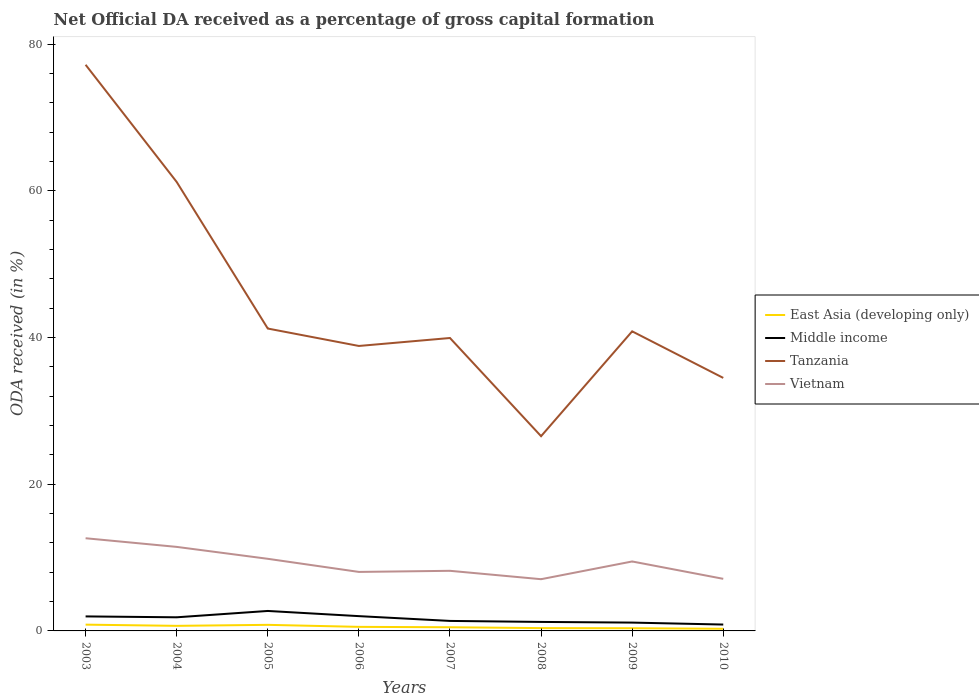Across all years, what is the maximum net ODA received in East Asia (developing only)?
Make the answer very short. 0.29. What is the total net ODA received in Middle income in the graph?
Provide a short and direct response. 0.63. What is the difference between the highest and the second highest net ODA received in East Asia (developing only)?
Offer a terse response. 0.56. What is the difference between the highest and the lowest net ODA received in East Asia (developing only)?
Your response must be concise. 3. Is the net ODA received in Tanzania strictly greater than the net ODA received in Middle income over the years?
Ensure brevity in your answer.  No. How many lines are there?
Give a very brief answer. 4. How many years are there in the graph?
Keep it short and to the point. 8. Does the graph contain grids?
Keep it short and to the point. No. How many legend labels are there?
Offer a terse response. 4. What is the title of the graph?
Offer a terse response. Net Official DA received as a percentage of gross capital formation. Does "France" appear as one of the legend labels in the graph?
Your answer should be compact. No. What is the label or title of the X-axis?
Your response must be concise. Years. What is the label or title of the Y-axis?
Your answer should be compact. ODA received (in %). What is the ODA received (in %) in East Asia (developing only) in 2003?
Your answer should be compact. 0.86. What is the ODA received (in %) in Middle income in 2003?
Your answer should be compact. 1.98. What is the ODA received (in %) in Tanzania in 2003?
Give a very brief answer. 77.21. What is the ODA received (in %) of Vietnam in 2003?
Offer a very short reply. 12.64. What is the ODA received (in %) of East Asia (developing only) in 2004?
Make the answer very short. 0.69. What is the ODA received (in %) in Middle income in 2004?
Provide a short and direct response. 1.86. What is the ODA received (in %) of Tanzania in 2004?
Make the answer very short. 61.23. What is the ODA received (in %) of Vietnam in 2004?
Keep it short and to the point. 11.46. What is the ODA received (in %) in East Asia (developing only) in 2005?
Make the answer very short. 0.83. What is the ODA received (in %) in Middle income in 2005?
Your response must be concise. 2.72. What is the ODA received (in %) in Tanzania in 2005?
Give a very brief answer. 41.24. What is the ODA received (in %) in Vietnam in 2005?
Make the answer very short. 9.84. What is the ODA received (in %) of East Asia (developing only) in 2006?
Offer a terse response. 0.55. What is the ODA received (in %) in Middle income in 2006?
Ensure brevity in your answer.  2.02. What is the ODA received (in %) of Tanzania in 2006?
Keep it short and to the point. 38.86. What is the ODA received (in %) in Vietnam in 2006?
Keep it short and to the point. 8.05. What is the ODA received (in %) of East Asia (developing only) in 2007?
Your answer should be very brief. 0.5. What is the ODA received (in %) in Middle income in 2007?
Your answer should be very brief. 1.36. What is the ODA received (in %) in Tanzania in 2007?
Keep it short and to the point. 39.95. What is the ODA received (in %) in Vietnam in 2007?
Ensure brevity in your answer.  8.2. What is the ODA received (in %) in East Asia (developing only) in 2008?
Offer a very short reply. 0.38. What is the ODA received (in %) of Middle income in 2008?
Your answer should be very brief. 1.23. What is the ODA received (in %) in Tanzania in 2008?
Ensure brevity in your answer.  26.56. What is the ODA received (in %) of Vietnam in 2008?
Provide a short and direct response. 7.05. What is the ODA received (in %) of East Asia (developing only) in 2009?
Ensure brevity in your answer.  0.37. What is the ODA received (in %) of Middle income in 2009?
Offer a very short reply. 1.14. What is the ODA received (in %) of Tanzania in 2009?
Provide a succinct answer. 40.86. What is the ODA received (in %) of Vietnam in 2009?
Make the answer very short. 9.47. What is the ODA received (in %) of East Asia (developing only) in 2010?
Keep it short and to the point. 0.29. What is the ODA received (in %) in Middle income in 2010?
Your answer should be compact. 0.87. What is the ODA received (in %) in Tanzania in 2010?
Your response must be concise. 34.51. What is the ODA received (in %) in Vietnam in 2010?
Give a very brief answer. 7.1. Across all years, what is the maximum ODA received (in %) of East Asia (developing only)?
Your response must be concise. 0.86. Across all years, what is the maximum ODA received (in %) in Middle income?
Your answer should be compact. 2.72. Across all years, what is the maximum ODA received (in %) of Tanzania?
Offer a very short reply. 77.21. Across all years, what is the maximum ODA received (in %) in Vietnam?
Offer a terse response. 12.64. Across all years, what is the minimum ODA received (in %) of East Asia (developing only)?
Ensure brevity in your answer.  0.29. Across all years, what is the minimum ODA received (in %) in Middle income?
Your answer should be compact. 0.87. Across all years, what is the minimum ODA received (in %) of Tanzania?
Your response must be concise. 26.56. Across all years, what is the minimum ODA received (in %) of Vietnam?
Make the answer very short. 7.05. What is the total ODA received (in %) in East Asia (developing only) in the graph?
Your answer should be compact. 4.48. What is the total ODA received (in %) in Middle income in the graph?
Ensure brevity in your answer.  13.17. What is the total ODA received (in %) in Tanzania in the graph?
Your response must be concise. 360.41. What is the total ODA received (in %) of Vietnam in the graph?
Provide a short and direct response. 73.81. What is the difference between the ODA received (in %) of East Asia (developing only) in 2003 and that in 2004?
Keep it short and to the point. 0.16. What is the difference between the ODA received (in %) in Middle income in 2003 and that in 2004?
Offer a terse response. 0.12. What is the difference between the ODA received (in %) in Tanzania in 2003 and that in 2004?
Give a very brief answer. 15.98. What is the difference between the ODA received (in %) in Vietnam in 2003 and that in 2004?
Your response must be concise. 1.18. What is the difference between the ODA received (in %) of East Asia (developing only) in 2003 and that in 2005?
Your answer should be compact. 0.03. What is the difference between the ODA received (in %) of Middle income in 2003 and that in 2005?
Provide a short and direct response. -0.74. What is the difference between the ODA received (in %) in Tanzania in 2003 and that in 2005?
Ensure brevity in your answer.  35.97. What is the difference between the ODA received (in %) in Vietnam in 2003 and that in 2005?
Give a very brief answer. 2.8. What is the difference between the ODA received (in %) in East Asia (developing only) in 2003 and that in 2006?
Your answer should be very brief. 0.3. What is the difference between the ODA received (in %) of Middle income in 2003 and that in 2006?
Offer a terse response. -0.04. What is the difference between the ODA received (in %) in Tanzania in 2003 and that in 2006?
Make the answer very short. 38.35. What is the difference between the ODA received (in %) of Vietnam in 2003 and that in 2006?
Provide a succinct answer. 4.59. What is the difference between the ODA received (in %) of East Asia (developing only) in 2003 and that in 2007?
Keep it short and to the point. 0.36. What is the difference between the ODA received (in %) of Middle income in 2003 and that in 2007?
Provide a short and direct response. 0.62. What is the difference between the ODA received (in %) in Tanzania in 2003 and that in 2007?
Provide a short and direct response. 37.26. What is the difference between the ODA received (in %) of Vietnam in 2003 and that in 2007?
Provide a short and direct response. 4.44. What is the difference between the ODA received (in %) in East Asia (developing only) in 2003 and that in 2008?
Your answer should be compact. 0.47. What is the difference between the ODA received (in %) of Middle income in 2003 and that in 2008?
Provide a succinct answer. 0.75. What is the difference between the ODA received (in %) in Tanzania in 2003 and that in 2008?
Ensure brevity in your answer.  50.65. What is the difference between the ODA received (in %) of Vietnam in 2003 and that in 2008?
Provide a short and direct response. 5.58. What is the difference between the ODA received (in %) in East Asia (developing only) in 2003 and that in 2009?
Offer a very short reply. 0.49. What is the difference between the ODA received (in %) of Middle income in 2003 and that in 2009?
Give a very brief answer. 0.84. What is the difference between the ODA received (in %) of Tanzania in 2003 and that in 2009?
Provide a succinct answer. 36.35. What is the difference between the ODA received (in %) of Vietnam in 2003 and that in 2009?
Provide a succinct answer. 3.17. What is the difference between the ODA received (in %) in East Asia (developing only) in 2003 and that in 2010?
Make the answer very short. 0.56. What is the difference between the ODA received (in %) in Middle income in 2003 and that in 2010?
Your response must be concise. 1.11. What is the difference between the ODA received (in %) of Tanzania in 2003 and that in 2010?
Your answer should be very brief. 42.7. What is the difference between the ODA received (in %) of Vietnam in 2003 and that in 2010?
Offer a terse response. 5.53. What is the difference between the ODA received (in %) of East Asia (developing only) in 2004 and that in 2005?
Provide a short and direct response. -0.14. What is the difference between the ODA received (in %) of Middle income in 2004 and that in 2005?
Offer a terse response. -0.86. What is the difference between the ODA received (in %) of Tanzania in 2004 and that in 2005?
Give a very brief answer. 19.99. What is the difference between the ODA received (in %) of Vietnam in 2004 and that in 2005?
Offer a terse response. 1.62. What is the difference between the ODA received (in %) in East Asia (developing only) in 2004 and that in 2006?
Make the answer very short. 0.14. What is the difference between the ODA received (in %) in Middle income in 2004 and that in 2006?
Ensure brevity in your answer.  -0.16. What is the difference between the ODA received (in %) of Tanzania in 2004 and that in 2006?
Make the answer very short. 22.37. What is the difference between the ODA received (in %) in Vietnam in 2004 and that in 2006?
Provide a short and direct response. 3.41. What is the difference between the ODA received (in %) in East Asia (developing only) in 2004 and that in 2007?
Keep it short and to the point. 0.19. What is the difference between the ODA received (in %) in Middle income in 2004 and that in 2007?
Offer a terse response. 0.5. What is the difference between the ODA received (in %) in Tanzania in 2004 and that in 2007?
Keep it short and to the point. 21.28. What is the difference between the ODA received (in %) in Vietnam in 2004 and that in 2007?
Your answer should be compact. 3.26. What is the difference between the ODA received (in %) in East Asia (developing only) in 2004 and that in 2008?
Keep it short and to the point. 0.31. What is the difference between the ODA received (in %) in Middle income in 2004 and that in 2008?
Your answer should be very brief. 0.63. What is the difference between the ODA received (in %) of Tanzania in 2004 and that in 2008?
Your answer should be very brief. 34.67. What is the difference between the ODA received (in %) in Vietnam in 2004 and that in 2008?
Provide a short and direct response. 4.41. What is the difference between the ODA received (in %) of East Asia (developing only) in 2004 and that in 2009?
Give a very brief answer. 0.33. What is the difference between the ODA received (in %) of Middle income in 2004 and that in 2009?
Offer a very short reply. 0.72. What is the difference between the ODA received (in %) in Tanzania in 2004 and that in 2009?
Provide a succinct answer. 20.37. What is the difference between the ODA received (in %) in Vietnam in 2004 and that in 2009?
Make the answer very short. 1.99. What is the difference between the ODA received (in %) in East Asia (developing only) in 2004 and that in 2010?
Keep it short and to the point. 0.4. What is the difference between the ODA received (in %) of Tanzania in 2004 and that in 2010?
Keep it short and to the point. 26.72. What is the difference between the ODA received (in %) of Vietnam in 2004 and that in 2010?
Offer a terse response. 4.35. What is the difference between the ODA received (in %) in East Asia (developing only) in 2005 and that in 2006?
Give a very brief answer. 0.27. What is the difference between the ODA received (in %) in Middle income in 2005 and that in 2006?
Keep it short and to the point. 0.71. What is the difference between the ODA received (in %) of Tanzania in 2005 and that in 2006?
Give a very brief answer. 2.38. What is the difference between the ODA received (in %) of Vietnam in 2005 and that in 2006?
Your answer should be very brief. 1.79. What is the difference between the ODA received (in %) of East Asia (developing only) in 2005 and that in 2007?
Provide a succinct answer. 0.33. What is the difference between the ODA received (in %) of Middle income in 2005 and that in 2007?
Keep it short and to the point. 1.36. What is the difference between the ODA received (in %) of Tanzania in 2005 and that in 2007?
Give a very brief answer. 1.29. What is the difference between the ODA received (in %) of Vietnam in 2005 and that in 2007?
Give a very brief answer. 1.64. What is the difference between the ODA received (in %) of East Asia (developing only) in 2005 and that in 2008?
Offer a very short reply. 0.45. What is the difference between the ODA received (in %) of Middle income in 2005 and that in 2008?
Offer a terse response. 1.49. What is the difference between the ODA received (in %) in Tanzania in 2005 and that in 2008?
Offer a very short reply. 14.68. What is the difference between the ODA received (in %) of Vietnam in 2005 and that in 2008?
Provide a short and direct response. 2.78. What is the difference between the ODA received (in %) of East Asia (developing only) in 2005 and that in 2009?
Provide a short and direct response. 0.46. What is the difference between the ODA received (in %) of Middle income in 2005 and that in 2009?
Your answer should be very brief. 1.59. What is the difference between the ODA received (in %) of Tanzania in 2005 and that in 2009?
Provide a succinct answer. 0.38. What is the difference between the ODA received (in %) in Vietnam in 2005 and that in 2009?
Ensure brevity in your answer.  0.36. What is the difference between the ODA received (in %) of East Asia (developing only) in 2005 and that in 2010?
Ensure brevity in your answer.  0.54. What is the difference between the ODA received (in %) in Middle income in 2005 and that in 2010?
Offer a very short reply. 1.85. What is the difference between the ODA received (in %) of Tanzania in 2005 and that in 2010?
Offer a terse response. 6.73. What is the difference between the ODA received (in %) in Vietnam in 2005 and that in 2010?
Your answer should be very brief. 2.73. What is the difference between the ODA received (in %) of East Asia (developing only) in 2006 and that in 2007?
Offer a very short reply. 0.05. What is the difference between the ODA received (in %) of Middle income in 2006 and that in 2007?
Offer a very short reply. 0.65. What is the difference between the ODA received (in %) of Tanzania in 2006 and that in 2007?
Your response must be concise. -1.09. What is the difference between the ODA received (in %) in Vietnam in 2006 and that in 2007?
Make the answer very short. -0.15. What is the difference between the ODA received (in %) in East Asia (developing only) in 2006 and that in 2008?
Your answer should be very brief. 0.17. What is the difference between the ODA received (in %) of Middle income in 2006 and that in 2008?
Your response must be concise. 0.79. What is the difference between the ODA received (in %) in Tanzania in 2006 and that in 2008?
Your answer should be compact. 12.3. What is the difference between the ODA received (in %) of East Asia (developing only) in 2006 and that in 2009?
Your response must be concise. 0.19. What is the difference between the ODA received (in %) in Middle income in 2006 and that in 2009?
Provide a short and direct response. 0.88. What is the difference between the ODA received (in %) in Tanzania in 2006 and that in 2009?
Offer a terse response. -1.99. What is the difference between the ODA received (in %) of Vietnam in 2006 and that in 2009?
Make the answer very short. -1.43. What is the difference between the ODA received (in %) of East Asia (developing only) in 2006 and that in 2010?
Ensure brevity in your answer.  0.26. What is the difference between the ODA received (in %) in Middle income in 2006 and that in 2010?
Offer a terse response. 1.15. What is the difference between the ODA received (in %) in Tanzania in 2006 and that in 2010?
Provide a succinct answer. 4.36. What is the difference between the ODA received (in %) in Vietnam in 2006 and that in 2010?
Provide a short and direct response. 0.94. What is the difference between the ODA received (in %) in East Asia (developing only) in 2007 and that in 2008?
Provide a short and direct response. 0.12. What is the difference between the ODA received (in %) in Middle income in 2007 and that in 2008?
Provide a short and direct response. 0.13. What is the difference between the ODA received (in %) in Tanzania in 2007 and that in 2008?
Give a very brief answer. 13.39. What is the difference between the ODA received (in %) in Vietnam in 2007 and that in 2008?
Provide a short and direct response. 1.14. What is the difference between the ODA received (in %) of East Asia (developing only) in 2007 and that in 2009?
Your answer should be compact. 0.13. What is the difference between the ODA received (in %) in Middle income in 2007 and that in 2009?
Your answer should be very brief. 0.23. What is the difference between the ODA received (in %) of Tanzania in 2007 and that in 2009?
Offer a very short reply. -0.91. What is the difference between the ODA received (in %) of Vietnam in 2007 and that in 2009?
Offer a terse response. -1.27. What is the difference between the ODA received (in %) in East Asia (developing only) in 2007 and that in 2010?
Give a very brief answer. 0.21. What is the difference between the ODA received (in %) of Middle income in 2007 and that in 2010?
Your answer should be very brief. 0.49. What is the difference between the ODA received (in %) in Tanzania in 2007 and that in 2010?
Provide a short and direct response. 5.44. What is the difference between the ODA received (in %) in Vietnam in 2007 and that in 2010?
Offer a very short reply. 1.09. What is the difference between the ODA received (in %) of East Asia (developing only) in 2008 and that in 2009?
Your answer should be very brief. 0.02. What is the difference between the ODA received (in %) of Middle income in 2008 and that in 2009?
Provide a short and direct response. 0.09. What is the difference between the ODA received (in %) in Tanzania in 2008 and that in 2009?
Provide a short and direct response. -14.3. What is the difference between the ODA received (in %) of Vietnam in 2008 and that in 2009?
Your answer should be compact. -2.42. What is the difference between the ODA received (in %) of East Asia (developing only) in 2008 and that in 2010?
Provide a short and direct response. 0.09. What is the difference between the ODA received (in %) in Middle income in 2008 and that in 2010?
Provide a succinct answer. 0.36. What is the difference between the ODA received (in %) of Tanzania in 2008 and that in 2010?
Provide a succinct answer. -7.95. What is the difference between the ODA received (in %) in Vietnam in 2008 and that in 2010?
Your answer should be compact. -0.05. What is the difference between the ODA received (in %) of East Asia (developing only) in 2009 and that in 2010?
Your answer should be very brief. 0.07. What is the difference between the ODA received (in %) in Middle income in 2009 and that in 2010?
Your response must be concise. 0.27. What is the difference between the ODA received (in %) in Tanzania in 2009 and that in 2010?
Give a very brief answer. 6.35. What is the difference between the ODA received (in %) in Vietnam in 2009 and that in 2010?
Your answer should be compact. 2.37. What is the difference between the ODA received (in %) of East Asia (developing only) in 2003 and the ODA received (in %) of Middle income in 2004?
Keep it short and to the point. -1. What is the difference between the ODA received (in %) in East Asia (developing only) in 2003 and the ODA received (in %) in Tanzania in 2004?
Your answer should be compact. -60.37. What is the difference between the ODA received (in %) in East Asia (developing only) in 2003 and the ODA received (in %) in Vietnam in 2004?
Keep it short and to the point. -10.6. What is the difference between the ODA received (in %) of Middle income in 2003 and the ODA received (in %) of Tanzania in 2004?
Provide a succinct answer. -59.25. What is the difference between the ODA received (in %) of Middle income in 2003 and the ODA received (in %) of Vietnam in 2004?
Your answer should be very brief. -9.48. What is the difference between the ODA received (in %) in Tanzania in 2003 and the ODA received (in %) in Vietnam in 2004?
Ensure brevity in your answer.  65.75. What is the difference between the ODA received (in %) of East Asia (developing only) in 2003 and the ODA received (in %) of Middle income in 2005?
Make the answer very short. -1.87. What is the difference between the ODA received (in %) in East Asia (developing only) in 2003 and the ODA received (in %) in Tanzania in 2005?
Ensure brevity in your answer.  -40.38. What is the difference between the ODA received (in %) of East Asia (developing only) in 2003 and the ODA received (in %) of Vietnam in 2005?
Provide a short and direct response. -8.98. What is the difference between the ODA received (in %) of Middle income in 2003 and the ODA received (in %) of Tanzania in 2005?
Keep it short and to the point. -39.26. What is the difference between the ODA received (in %) in Middle income in 2003 and the ODA received (in %) in Vietnam in 2005?
Offer a very short reply. -7.86. What is the difference between the ODA received (in %) of Tanzania in 2003 and the ODA received (in %) of Vietnam in 2005?
Your answer should be compact. 67.37. What is the difference between the ODA received (in %) in East Asia (developing only) in 2003 and the ODA received (in %) in Middle income in 2006?
Your answer should be very brief. -1.16. What is the difference between the ODA received (in %) in East Asia (developing only) in 2003 and the ODA received (in %) in Tanzania in 2006?
Provide a succinct answer. -38.01. What is the difference between the ODA received (in %) of East Asia (developing only) in 2003 and the ODA received (in %) of Vietnam in 2006?
Your response must be concise. -7.19. What is the difference between the ODA received (in %) in Middle income in 2003 and the ODA received (in %) in Tanzania in 2006?
Your response must be concise. -36.88. What is the difference between the ODA received (in %) in Middle income in 2003 and the ODA received (in %) in Vietnam in 2006?
Ensure brevity in your answer.  -6.07. What is the difference between the ODA received (in %) of Tanzania in 2003 and the ODA received (in %) of Vietnam in 2006?
Give a very brief answer. 69.16. What is the difference between the ODA received (in %) of East Asia (developing only) in 2003 and the ODA received (in %) of Middle income in 2007?
Provide a short and direct response. -0.51. What is the difference between the ODA received (in %) in East Asia (developing only) in 2003 and the ODA received (in %) in Tanzania in 2007?
Offer a terse response. -39.09. What is the difference between the ODA received (in %) of East Asia (developing only) in 2003 and the ODA received (in %) of Vietnam in 2007?
Offer a very short reply. -7.34. What is the difference between the ODA received (in %) of Middle income in 2003 and the ODA received (in %) of Tanzania in 2007?
Your response must be concise. -37.97. What is the difference between the ODA received (in %) in Middle income in 2003 and the ODA received (in %) in Vietnam in 2007?
Keep it short and to the point. -6.22. What is the difference between the ODA received (in %) of Tanzania in 2003 and the ODA received (in %) of Vietnam in 2007?
Offer a very short reply. 69.01. What is the difference between the ODA received (in %) of East Asia (developing only) in 2003 and the ODA received (in %) of Middle income in 2008?
Your response must be concise. -0.37. What is the difference between the ODA received (in %) in East Asia (developing only) in 2003 and the ODA received (in %) in Tanzania in 2008?
Offer a very short reply. -25.7. What is the difference between the ODA received (in %) of East Asia (developing only) in 2003 and the ODA received (in %) of Vietnam in 2008?
Offer a terse response. -6.2. What is the difference between the ODA received (in %) of Middle income in 2003 and the ODA received (in %) of Tanzania in 2008?
Ensure brevity in your answer.  -24.58. What is the difference between the ODA received (in %) in Middle income in 2003 and the ODA received (in %) in Vietnam in 2008?
Offer a terse response. -5.07. What is the difference between the ODA received (in %) of Tanzania in 2003 and the ODA received (in %) of Vietnam in 2008?
Your answer should be very brief. 70.16. What is the difference between the ODA received (in %) of East Asia (developing only) in 2003 and the ODA received (in %) of Middle income in 2009?
Provide a succinct answer. -0.28. What is the difference between the ODA received (in %) of East Asia (developing only) in 2003 and the ODA received (in %) of Tanzania in 2009?
Your answer should be very brief. -40. What is the difference between the ODA received (in %) of East Asia (developing only) in 2003 and the ODA received (in %) of Vietnam in 2009?
Provide a succinct answer. -8.62. What is the difference between the ODA received (in %) in Middle income in 2003 and the ODA received (in %) in Tanzania in 2009?
Ensure brevity in your answer.  -38.88. What is the difference between the ODA received (in %) in Middle income in 2003 and the ODA received (in %) in Vietnam in 2009?
Your answer should be compact. -7.49. What is the difference between the ODA received (in %) in Tanzania in 2003 and the ODA received (in %) in Vietnam in 2009?
Ensure brevity in your answer.  67.74. What is the difference between the ODA received (in %) of East Asia (developing only) in 2003 and the ODA received (in %) of Middle income in 2010?
Your response must be concise. -0.01. What is the difference between the ODA received (in %) in East Asia (developing only) in 2003 and the ODA received (in %) in Tanzania in 2010?
Keep it short and to the point. -33.65. What is the difference between the ODA received (in %) in East Asia (developing only) in 2003 and the ODA received (in %) in Vietnam in 2010?
Provide a succinct answer. -6.25. What is the difference between the ODA received (in %) in Middle income in 2003 and the ODA received (in %) in Tanzania in 2010?
Provide a succinct answer. -32.53. What is the difference between the ODA received (in %) of Middle income in 2003 and the ODA received (in %) of Vietnam in 2010?
Offer a very short reply. -5.13. What is the difference between the ODA received (in %) in Tanzania in 2003 and the ODA received (in %) in Vietnam in 2010?
Provide a succinct answer. 70.1. What is the difference between the ODA received (in %) of East Asia (developing only) in 2004 and the ODA received (in %) of Middle income in 2005?
Provide a short and direct response. -2.03. What is the difference between the ODA received (in %) of East Asia (developing only) in 2004 and the ODA received (in %) of Tanzania in 2005?
Your answer should be very brief. -40.54. What is the difference between the ODA received (in %) in East Asia (developing only) in 2004 and the ODA received (in %) in Vietnam in 2005?
Your answer should be very brief. -9.14. What is the difference between the ODA received (in %) of Middle income in 2004 and the ODA received (in %) of Tanzania in 2005?
Your response must be concise. -39.38. What is the difference between the ODA received (in %) of Middle income in 2004 and the ODA received (in %) of Vietnam in 2005?
Offer a terse response. -7.98. What is the difference between the ODA received (in %) of Tanzania in 2004 and the ODA received (in %) of Vietnam in 2005?
Make the answer very short. 51.39. What is the difference between the ODA received (in %) in East Asia (developing only) in 2004 and the ODA received (in %) in Middle income in 2006?
Provide a succinct answer. -1.32. What is the difference between the ODA received (in %) in East Asia (developing only) in 2004 and the ODA received (in %) in Tanzania in 2006?
Offer a terse response. -38.17. What is the difference between the ODA received (in %) in East Asia (developing only) in 2004 and the ODA received (in %) in Vietnam in 2006?
Make the answer very short. -7.35. What is the difference between the ODA received (in %) in Middle income in 2004 and the ODA received (in %) in Tanzania in 2006?
Ensure brevity in your answer.  -37. What is the difference between the ODA received (in %) in Middle income in 2004 and the ODA received (in %) in Vietnam in 2006?
Give a very brief answer. -6.19. What is the difference between the ODA received (in %) of Tanzania in 2004 and the ODA received (in %) of Vietnam in 2006?
Offer a very short reply. 53.18. What is the difference between the ODA received (in %) of East Asia (developing only) in 2004 and the ODA received (in %) of Middle income in 2007?
Offer a terse response. -0.67. What is the difference between the ODA received (in %) of East Asia (developing only) in 2004 and the ODA received (in %) of Tanzania in 2007?
Make the answer very short. -39.25. What is the difference between the ODA received (in %) in East Asia (developing only) in 2004 and the ODA received (in %) in Vietnam in 2007?
Offer a very short reply. -7.5. What is the difference between the ODA received (in %) of Middle income in 2004 and the ODA received (in %) of Tanzania in 2007?
Give a very brief answer. -38.09. What is the difference between the ODA received (in %) of Middle income in 2004 and the ODA received (in %) of Vietnam in 2007?
Give a very brief answer. -6.34. What is the difference between the ODA received (in %) in Tanzania in 2004 and the ODA received (in %) in Vietnam in 2007?
Provide a succinct answer. 53.03. What is the difference between the ODA received (in %) in East Asia (developing only) in 2004 and the ODA received (in %) in Middle income in 2008?
Ensure brevity in your answer.  -0.53. What is the difference between the ODA received (in %) of East Asia (developing only) in 2004 and the ODA received (in %) of Tanzania in 2008?
Make the answer very short. -25.86. What is the difference between the ODA received (in %) in East Asia (developing only) in 2004 and the ODA received (in %) in Vietnam in 2008?
Provide a succinct answer. -6.36. What is the difference between the ODA received (in %) of Middle income in 2004 and the ODA received (in %) of Tanzania in 2008?
Your response must be concise. -24.7. What is the difference between the ODA received (in %) of Middle income in 2004 and the ODA received (in %) of Vietnam in 2008?
Offer a terse response. -5.2. What is the difference between the ODA received (in %) of Tanzania in 2004 and the ODA received (in %) of Vietnam in 2008?
Ensure brevity in your answer.  54.17. What is the difference between the ODA received (in %) of East Asia (developing only) in 2004 and the ODA received (in %) of Middle income in 2009?
Give a very brief answer. -0.44. What is the difference between the ODA received (in %) of East Asia (developing only) in 2004 and the ODA received (in %) of Tanzania in 2009?
Provide a succinct answer. -40.16. What is the difference between the ODA received (in %) in East Asia (developing only) in 2004 and the ODA received (in %) in Vietnam in 2009?
Offer a terse response. -8.78. What is the difference between the ODA received (in %) of Middle income in 2004 and the ODA received (in %) of Tanzania in 2009?
Give a very brief answer. -39. What is the difference between the ODA received (in %) in Middle income in 2004 and the ODA received (in %) in Vietnam in 2009?
Keep it short and to the point. -7.61. What is the difference between the ODA received (in %) of Tanzania in 2004 and the ODA received (in %) of Vietnam in 2009?
Offer a terse response. 51.76. What is the difference between the ODA received (in %) of East Asia (developing only) in 2004 and the ODA received (in %) of Middle income in 2010?
Your answer should be compact. -0.18. What is the difference between the ODA received (in %) of East Asia (developing only) in 2004 and the ODA received (in %) of Tanzania in 2010?
Provide a succinct answer. -33.81. What is the difference between the ODA received (in %) of East Asia (developing only) in 2004 and the ODA received (in %) of Vietnam in 2010?
Keep it short and to the point. -6.41. What is the difference between the ODA received (in %) in Middle income in 2004 and the ODA received (in %) in Tanzania in 2010?
Your answer should be compact. -32.65. What is the difference between the ODA received (in %) in Middle income in 2004 and the ODA received (in %) in Vietnam in 2010?
Make the answer very short. -5.25. What is the difference between the ODA received (in %) in Tanzania in 2004 and the ODA received (in %) in Vietnam in 2010?
Provide a short and direct response. 54.12. What is the difference between the ODA received (in %) in East Asia (developing only) in 2005 and the ODA received (in %) in Middle income in 2006?
Keep it short and to the point. -1.19. What is the difference between the ODA received (in %) in East Asia (developing only) in 2005 and the ODA received (in %) in Tanzania in 2006?
Your answer should be very brief. -38.03. What is the difference between the ODA received (in %) in East Asia (developing only) in 2005 and the ODA received (in %) in Vietnam in 2006?
Your answer should be very brief. -7.22. What is the difference between the ODA received (in %) of Middle income in 2005 and the ODA received (in %) of Tanzania in 2006?
Give a very brief answer. -36.14. What is the difference between the ODA received (in %) in Middle income in 2005 and the ODA received (in %) in Vietnam in 2006?
Offer a very short reply. -5.32. What is the difference between the ODA received (in %) of Tanzania in 2005 and the ODA received (in %) of Vietnam in 2006?
Offer a terse response. 33.19. What is the difference between the ODA received (in %) of East Asia (developing only) in 2005 and the ODA received (in %) of Middle income in 2007?
Give a very brief answer. -0.53. What is the difference between the ODA received (in %) of East Asia (developing only) in 2005 and the ODA received (in %) of Tanzania in 2007?
Make the answer very short. -39.12. What is the difference between the ODA received (in %) in East Asia (developing only) in 2005 and the ODA received (in %) in Vietnam in 2007?
Your answer should be very brief. -7.37. What is the difference between the ODA received (in %) in Middle income in 2005 and the ODA received (in %) in Tanzania in 2007?
Ensure brevity in your answer.  -37.23. What is the difference between the ODA received (in %) of Middle income in 2005 and the ODA received (in %) of Vietnam in 2007?
Offer a terse response. -5.47. What is the difference between the ODA received (in %) of Tanzania in 2005 and the ODA received (in %) of Vietnam in 2007?
Make the answer very short. 33.04. What is the difference between the ODA received (in %) of East Asia (developing only) in 2005 and the ODA received (in %) of Middle income in 2008?
Ensure brevity in your answer.  -0.4. What is the difference between the ODA received (in %) of East Asia (developing only) in 2005 and the ODA received (in %) of Tanzania in 2008?
Ensure brevity in your answer.  -25.73. What is the difference between the ODA received (in %) of East Asia (developing only) in 2005 and the ODA received (in %) of Vietnam in 2008?
Your answer should be very brief. -6.22. What is the difference between the ODA received (in %) in Middle income in 2005 and the ODA received (in %) in Tanzania in 2008?
Provide a short and direct response. -23.84. What is the difference between the ODA received (in %) in Middle income in 2005 and the ODA received (in %) in Vietnam in 2008?
Ensure brevity in your answer.  -4.33. What is the difference between the ODA received (in %) of Tanzania in 2005 and the ODA received (in %) of Vietnam in 2008?
Offer a very short reply. 34.18. What is the difference between the ODA received (in %) of East Asia (developing only) in 2005 and the ODA received (in %) of Middle income in 2009?
Offer a very short reply. -0.31. What is the difference between the ODA received (in %) of East Asia (developing only) in 2005 and the ODA received (in %) of Tanzania in 2009?
Your response must be concise. -40.03. What is the difference between the ODA received (in %) in East Asia (developing only) in 2005 and the ODA received (in %) in Vietnam in 2009?
Your answer should be very brief. -8.64. What is the difference between the ODA received (in %) in Middle income in 2005 and the ODA received (in %) in Tanzania in 2009?
Your answer should be very brief. -38.13. What is the difference between the ODA received (in %) in Middle income in 2005 and the ODA received (in %) in Vietnam in 2009?
Offer a very short reply. -6.75. What is the difference between the ODA received (in %) of Tanzania in 2005 and the ODA received (in %) of Vietnam in 2009?
Give a very brief answer. 31.77. What is the difference between the ODA received (in %) in East Asia (developing only) in 2005 and the ODA received (in %) in Middle income in 2010?
Your answer should be very brief. -0.04. What is the difference between the ODA received (in %) in East Asia (developing only) in 2005 and the ODA received (in %) in Tanzania in 2010?
Keep it short and to the point. -33.68. What is the difference between the ODA received (in %) of East Asia (developing only) in 2005 and the ODA received (in %) of Vietnam in 2010?
Offer a terse response. -6.28. What is the difference between the ODA received (in %) in Middle income in 2005 and the ODA received (in %) in Tanzania in 2010?
Offer a very short reply. -31.78. What is the difference between the ODA received (in %) in Middle income in 2005 and the ODA received (in %) in Vietnam in 2010?
Offer a very short reply. -4.38. What is the difference between the ODA received (in %) in Tanzania in 2005 and the ODA received (in %) in Vietnam in 2010?
Offer a terse response. 34.13. What is the difference between the ODA received (in %) of East Asia (developing only) in 2006 and the ODA received (in %) of Middle income in 2007?
Provide a succinct answer. -0.81. What is the difference between the ODA received (in %) in East Asia (developing only) in 2006 and the ODA received (in %) in Tanzania in 2007?
Your answer should be very brief. -39.39. What is the difference between the ODA received (in %) in East Asia (developing only) in 2006 and the ODA received (in %) in Vietnam in 2007?
Make the answer very short. -7.64. What is the difference between the ODA received (in %) in Middle income in 2006 and the ODA received (in %) in Tanzania in 2007?
Provide a succinct answer. -37.93. What is the difference between the ODA received (in %) in Middle income in 2006 and the ODA received (in %) in Vietnam in 2007?
Offer a very short reply. -6.18. What is the difference between the ODA received (in %) in Tanzania in 2006 and the ODA received (in %) in Vietnam in 2007?
Ensure brevity in your answer.  30.66. What is the difference between the ODA received (in %) of East Asia (developing only) in 2006 and the ODA received (in %) of Middle income in 2008?
Your response must be concise. -0.67. What is the difference between the ODA received (in %) in East Asia (developing only) in 2006 and the ODA received (in %) in Tanzania in 2008?
Provide a short and direct response. -26. What is the difference between the ODA received (in %) in East Asia (developing only) in 2006 and the ODA received (in %) in Vietnam in 2008?
Provide a short and direct response. -6.5. What is the difference between the ODA received (in %) of Middle income in 2006 and the ODA received (in %) of Tanzania in 2008?
Offer a very short reply. -24.54. What is the difference between the ODA received (in %) in Middle income in 2006 and the ODA received (in %) in Vietnam in 2008?
Your answer should be very brief. -5.04. What is the difference between the ODA received (in %) in Tanzania in 2006 and the ODA received (in %) in Vietnam in 2008?
Keep it short and to the point. 31.81. What is the difference between the ODA received (in %) of East Asia (developing only) in 2006 and the ODA received (in %) of Middle income in 2009?
Ensure brevity in your answer.  -0.58. What is the difference between the ODA received (in %) of East Asia (developing only) in 2006 and the ODA received (in %) of Tanzania in 2009?
Give a very brief answer. -40.3. What is the difference between the ODA received (in %) of East Asia (developing only) in 2006 and the ODA received (in %) of Vietnam in 2009?
Your answer should be compact. -8.92. What is the difference between the ODA received (in %) of Middle income in 2006 and the ODA received (in %) of Tanzania in 2009?
Keep it short and to the point. -38.84. What is the difference between the ODA received (in %) in Middle income in 2006 and the ODA received (in %) in Vietnam in 2009?
Give a very brief answer. -7.46. What is the difference between the ODA received (in %) in Tanzania in 2006 and the ODA received (in %) in Vietnam in 2009?
Your answer should be compact. 29.39. What is the difference between the ODA received (in %) in East Asia (developing only) in 2006 and the ODA received (in %) in Middle income in 2010?
Your response must be concise. -0.32. What is the difference between the ODA received (in %) of East Asia (developing only) in 2006 and the ODA received (in %) of Tanzania in 2010?
Provide a succinct answer. -33.95. What is the difference between the ODA received (in %) of East Asia (developing only) in 2006 and the ODA received (in %) of Vietnam in 2010?
Offer a terse response. -6.55. What is the difference between the ODA received (in %) of Middle income in 2006 and the ODA received (in %) of Tanzania in 2010?
Offer a very short reply. -32.49. What is the difference between the ODA received (in %) of Middle income in 2006 and the ODA received (in %) of Vietnam in 2010?
Make the answer very short. -5.09. What is the difference between the ODA received (in %) in Tanzania in 2006 and the ODA received (in %) in Vietnam in 2010?
Your response must be concise. 31.76. What is the difference between the ODA received (in %) of East Asia (developing only) in 2007 and the ODA received (in %) of Middle income in 2008?
Make the answer very short. -0.73. What is the difference between the ODA received (in %) in East Asia (developing only) in 2007 and the ODA received (in %) in Tanzania in 2008?
Keep it short and to the point. -26.06. What is the difference between the ODA received (in %) of East Asia (developing only) in 2007 and the ODA received (in %) of Vietnam in 2008?
Provide a succinct answer. -6.55. What is the difference between the ODA received (in %) of Middle income in 2007 and the ODA received (in %) of Tanzania in 2008?
Offer a terse response. -25.2. What is the difference between the ODA received (in %) in Middle income in 2007 and the ODA received (in %) in Vietnam in 2008?
Ensure brevity in your answer.  -5.69. What is the difference between the ODA received (in %) of Tanzania in 2007 and the ODA received (in %) of Vietnam in 2008?
Make the answer very short. 32.89. What is the difference between the ODA received (in %) in East Asia (developing only) in 2007 and the ODA received (in %) in Middle income in 2009?
Your answer should be very brief. -0.64. What is the difference between the ODA received (in %) in East Asia (developing only) in 2007 and the ODA received (in %) in Tanzania in 2009?
Ensure brevity in your answer.  -40.36. What is the difference between the ODA received (in %) of East Asia (developing only) in 2007 and the ODA received (in %) of Vietnam in 2009?
Provide a succinct answer. -8.97. What is the difference between the ODA received (in %) of Middle income in 2007 and the ODA received (in %) of Tanzania in 2009?
Keep it short and to the point. -39.49. What is the difference between the ODA received (in %) of Middle income in 2007 and the ODA received (in %) of Vietnam in 2009?
Offer a very short reply. -8.11. What is the difference between the ODA received (in %) in Tanzania in 2007 and the ODA received (in %) in Vietnam in 2009?
Keep it short and to the point. 30.48. What is the difference between the ODA received (in %) in East Asia (developing only) in 2007 and the ODA received (in %) in Middle income in 2010?
Provide a succinct answer. -0.37. What is the difference between the ODA received (in %) of East Asia (developing only) in 2007 and the ODA received (in %) of Tanzania in 2010?
Your answer should be very brief. -34.01. What is the difference between the ODA received (in %) of East Asia (developing only) in 2007 and the ODA received (in %) of Vietnam in 2010?
Make the answer very short. -6.61. What is the difference between the ODA received (in %) of Middle income in 2007 and the ODA received (in %) of Tanzania in 2010?
Give a very brief answer. -33.14. What is the difference between the ODA received (in %) in Middle income in 2007 and the ODA received (in %) in Vietnam in 2010?
Make the answer very short. -5.74. What is the difference between the ODA received (in %) of Tanzania in 2007 and the ODA received (in %) of Vietnam in 2010?
Your response must be concise. 32.84. What is the difference between the ODA received (in %) of East Asia (developing only) in 2008 and the ODA received (in %) of Middle income in 2009?
Provide a succinct answer. -0.75. What is the difference between the ODA received (in %) of East Asia (developing only) in 2008 and the ODA received (in %) of Tanzania in 2009?
Your response must be concise. -40.47. What is the difference between the ODA received (in %) of East Asia (developing only) in 2008 and the ODA received (in %) of Vietnam in 2009?
Your answer should be very brief. -9.09. What is the difference between the ODA received (in %) in Middle income in 2008 and the ODA received (in %) in Tanzania in 2009?
Provide a short and direct response. -39.63. What is the difference between the ODA received (in %) in Middle income in 2008 and the ODA received (in %) in Vietnam in 2009?
Ensure brevity in your answer.  -8.24. What is the difference between the ODA received (in %) of Tanzania in 2008 and the ODA received (in %) of Vietnam in 2009?
Provide a short and direct response. 17.09. What is the difference between the ODA received (in %) in East Asia (developing only) in 2008 and the ODA received (in %) in Middle income in 2010?
Provide a succinct answer. -0.49. What is the difference between the ODA received (in %) of East Asia (developing only) in 2008 and the ODA received (in %) of Tanzania in 2010?
Offer a terse response. -34.12. What is the difference between the ODA received (in %) in East Asia (developing only) in 2008 and the ODA received (in %) in Vietnam in 2010?
Provide a short and direct response. -6.72. What is the difference between the ODA received (in %) of Middle income in 2008 and the ODA received (in %) of Tanzania in 2010?
Offer a terse response. -33.28. What is the difference between the ODA received (in %) of Middle income in 2008 and the ODA received (in %) of Vietnam in 2010?
Your response must be concise. -5.88. What is the difference between the ODA received (in %) of Tanzania in 2008 and the ODA received (in %) of Vietnam in 2010?
Give a very brief answer. 19.45. What is the difference between the ODA received (in %) in East Asia (developing only) in 2009 and the ODA received (in %) in Middle income in 2010?
Provide a succinct answer. -0.5. What is the difference between the ODA received (in %) of East Asia (developing only) in 2009 and the ODA received (in %) of Tanzania in 2010?
Offer a very short reply. -34.14. What is the difference between the ODA received (in %) of East Asia (developing only) in 2009 and the ODA received (in %) of Vietnam in 2010?
Give a very brief answer. -6.74. What is the difference between the ODA received (in %) of Middle income in 2009 and the ODA received (in %) of Tanzania in 2010?
Give a very brief answer. -33.37. What is the difference between the ODA received (in %) in Middle income in 2009 and the ODA received (in %) in Vietnam in 2010?
Give a very brief answer. -5.97. What is the difference between the ODA received (in %) in Tanzania in 2009 and the ODA received (in %) in Vietnam in 2010?
Provide a succinct answer. 33.75. What is the average ODA received (in %) of East Asia (developing only) per year?
Ensure brevity in your answer.  0.56. What is the average ODA received (in %) in Middle income per year?
Make the answer very short. 1.65. What is the average ODA received (in %) in Tanzania per year?
Offer a very short reply. 45.05. What is the average ODA received (in %) of Vietnam per year?
Your answer should be compact. 9.23. In the year 2003, what is the difference between the ODA received (in %) of East Asia (developing only) and ODA received (in %) of Middle income?
Provide a short and direct response. -1.12. In the year 2003, what is the difference between the ODA received (in %) of East Asia (developing only) and ODA received (in %) of Tanzania?
Make the answer very short. -76.35. In the year 2003, what is the difference between the ODA received (in %) of East Asia (developing only) and ODA received (in %) of Vietnam?
Your answer should be very brief. -11.78. In the year 2003, what is the difference between the ODA received (in %) of Middle income and ODA received (in %) of Tanzania?
Make the answer very short. -75.23. In the year 2003, what is the difference between the ODA received (in %) of Middle income and ODA received (in %) of Vietnam?
Your answer should be very brief. -10.66. In the year 2003, what is the difference between the ODA received (in %) in Tanzania and ODA received (in %) in Vietnam?
Offer a terse response. 64.57. In the year 2004, what is the difference between the ODA received (in %) in East Asia (developing only) and ODA received (in %) in Middle income?
Offer a very short reply. -1.17. In the year 2004, what is the difference between the ODA received (in %) of East Asia (developing only) and ODA received (in %) of Tanzania?
Offer a terse response. -60.53. In the year 2004, what is the difference between the ODA received (in %) in East Asia (developing only) and ODA received (in %) in Vietnam?
Make the answer very short. -10.77. In the year 2004, what is the difference between the ODA received (in %) in Middle income and ODA received (in %) in Tanzania?
Make the answer very short. -59.37. In the year 2004, what is the difference between the ODA received (in %) of Middle income and ODA received (in %) of Vietnam?
Ensure brevity in your answer.  -9.6. In the year 2004, what is the difference between the ODA received (in %) in Tanzania and ODA received (in %) in Vietnam?
Provide a succinct answer. 49.77. In the year 2005, what is the difference between the ODA received (in %) of East Asia (developing only) and ODA received (in %) of Middle income?
Your answer should be very brief. -1.89. In the year 2005, what is the difference between the ODA received (in %) of East Asia (developing only) and ODA received (in %) of Tanzania?
Offer a terse response. -40.41. In the year 2005, what is the difference between the ODA received (in %) in East Asia (developing only) and ODA received (in %) in Vietnam?
Your answer should be compact. -9.01. In the year 2005, what is the difference between the ODA received (in %) of Middle income and ODA received (in %) of Tanzania?
Keep it short and to the point. -38.52. In the year 2005, what is the difference between the ODA received (in %) of Middle income and ODA received (in %) of Vietnam?
Ensure brevity in your answer.  -7.11. In the year 2005, what is the difference between the ODA received (in %) in Tanzania and ODA received (in %) in Vietnam?
Provide a short and direct response. 31.4. In the year 2006, what is the difference between the ODA received (in %) in East Asia (developing only) and ODA received (in %) in Middle income?
Keep it short and to the point. -1.46. In the year 2006, what is the difference between the ODA received (in %) of East Asia (developing only) and ODA received (in %) of Tanzania?
Make the answer very short. -38.31. In the year 2006, what is the difference between the ODA received (in %) of East Asia (developing only) and ODA received (in %) of Vietnam?
Ensure brevity in your answer.  -7.49. In the year 2006, what is the difference between the ODA received (in %) in Middle income and ODA received (in %) in Tanzania?
Keep it short and to the point. -36.85. In the year 2006, what is the difference between the ODA received (in %) in Middle income and ODA received (in %) in Vietnam?
Ensure brevity in your answer.  -6.03. In the year 2006, what is the difference between the ODA received (in %) in Tanzania and ODA received (in %) in Vietnam?
Ensure brevity in your answer.  30.82. In the year 2007, what is the difference between the ODA received (in %) of East Asia (developing only) and ODA received (in %) of Middle income?
Your answer should be compact. -0.86. In the year 2007, what is the difference between the ODA received (in %) of East Asia (developing only) and ODA received (in %) of Tanzania?
Offer a very short reply. -39.45. In the year 2007, what is the difference between the ODA received (in %) in East Asia (developing only) and ODA received (in %) in Vietnam?
Your answer should be compact. -7.7. In the year 2007, what is the difference between the ODA received (in %) in Middle income and ODA received (in %) in Tanzania?
Offer a very short reply. -38.58. In the year 2007, what is the difference between the ODA received (in %) in Middle income and ODA received (in %) in Vietnam?
Offer a terse response. -6.83. In the year 2007, what is the difference between the ODA received (in %) of Tanzania and ODA received (in %) of Vietnam?
Provide a succinct answer. 31.75. In the year 2008, what is the difference between the ODA received (in %) of East Asia (developing only) and ODA received (in %) of Middle income?
Keep it short and to the point. -0.84. In the year 2008, what is the difference between the ODA received (in %) of East Asia (developing only) and ODA received (in %) of Tanzania?
Provide a short and direct response. -26.17. In the year 2008, what is the difference between the ODA received (in %) in East Asia (developing only) and ODA received (in %) in Vietnam?
Make the answer very short. -6.67. In the year 2008, what is the difference between the ODA received (in %) of Middle income and ODA received (in %) of Tanzania?
Your response must be concise. -25.33. In the year 2008, what is the difference between the ODA received (in %) in Middle income and ODA received (in %) in Vietnam?
Your answer should be very brief. -5.83. In the year 2008, what is the difference between the ODA received (in %) of Tanzania and ODA received (in %) of Vietnam?
Offer a terse response. 19.5. In the year 2009, what is the difference between the ODA received (in %) in East Asia (developing only) and ODA received (in %) in Middle income?
Keep it short and to the point. -0.77. In the year 2009, what is the difference between the ODA received (in %) of East Asia (developing only) and ODA received (in %) of Tanzania?
Keep it short and to the point. -40.49. In the year 2009, what is the difference between the ODA received (in %) in East Asia (developing only) and ODA received (in %) in Vietnam?
Give a very brief answer. -9.11. In the year 2009, what is the difference between the ODA received (in %) of Middle income and ODA received (in %) of Tanzania?
Your response must be concise. -39.72. In the year 2009, what is the difference between the ODA received (in %) in Middle income and ODA received (in %) in Vietnam?
Your answer should be very brief. -8.34. In the year 2009, what is the difference between the ODA received (in %) in Tanzania and ODA received (in %) in Vietnam?
Make the answer very short. 31.38. In the year 2010, what is the difference between the ODA received (in %) in East Asia (developing only) and ODA received (in %) in Middle income?
Your response must be concise. -0.58. In the year 2010, what is the difference between the ODA received (in %) of East Asia (developing only) and ODA received (in %) of Tanzania?
Make the answer very short. -34.21. In the year 2010, what is the difference between the ODA received (in %) in East Asia (developing only) and ODA received (in %) in Vietnam?
Your answer should be compact. -6.81. In the year 2010, what is the difference between the ODA received (in %) in Middle income and ODA received (in %) in Tanzania?
Your answer should be compact. -33.64. In the year 2010, what is the difference between the ODA received (in %) in Middle income and ODA received (in %) in Vietnam?
Your answer should be compact. -6.23. In the year 2010, what is the difference between the ODA received (in %) of Tanzania and ODA received (in %) of Vietnam?
Provide a short and direct response. 27.4. What is the ratio of the ODA received (in %) of East Asia (developing only) in 2003 to that in 2004?
Offer a terse response. 1.24. What is the ratio of the ODA received (in %) in Middle income in 2003 to that in 2004?
Give a very brief answer. 1.07. What is the ratio of the ODA received (in %) in Tanzania in 2003 to that in 2004?
Make the answer very short. 1.26. What is the ratio of the ODA received (in %) in Vietnam in 2003 to that in 2004?
Provide a succinct answer. 1.1. What is the ratio of the ODA received (in %) of East Asia (developing only) in 2003 to that in 2005?
Provide a short and direct response. 1.03. What is the ratio of the ODA received (in %) in Middle income in 2003 to that in 2005?
Your answer should be compact. 0.73. What is the ratio of the ODA received (in %) in Tanzania in 2003 to that in 2005?
Provide a short and direct response. 1.87. What is the ratio of the ODA received (in %) of Vietnam in 2003 to that in 2005?
Ensure brevity in your answer.  1.29. What is the ratio of the ODA received (in %) of East Asia (developing only) in 2003 to that in 2006?
Keep it short and to the point. 1.54. What is the ratio of the ODA received (in %) of Middle income in 2003 to that in 2006?
Provide a short and direct response. 0.98. What is the ratio of the ODA received (in %) in Tanzania in 2003 to that in 2006?
Keep it short and to the point. 1.99. What is the ratio of the ODA received (in %) of Vietnam in 2003 to that in 2006?
Your answer should be very brief. 1.57. What is the ratio of the ODA received (in %) in East Asia (developing only) in 2003 to that in 2007?
Ensure brevity in your answer.  1.71. What is the ratio of the ODA received (in %) in Middle income in 2003 to that in 2007?
Ensure brevity in your answer.  1.45. What is the ratio of the ODA received (in %) in Tanzania in 2003 to that in 2007?
Your answer should be compact. 1.93. What is the ratio of the ODA received (in %) of Vietnam in 2003 to that in 2007?
Your answer should be compact. 1.54. What is the ratio of the ODA received (in %) of East Asia (developing only) in 2003 to that in 2008?
Provide a succinct answer. 2.23. What is the ratio of the ODA received (in %) of Middle income in 2003 to that in 2008?
Offer a terse response. 1.61. What is the ratio of the ODA received (in %) of Tanzania in 2003 to that in 2008?
Your answer should be very brief. 2.91. What is the ratio of the ODA received (in %) of Vietnam in 2003 to that in 2008?
Provide a succinct answer. 1.79. What is the ratio of the ODA received (in %) in East Asia (developing only) in 2003 to that in 2009?
Your answer should be very brief. 2.34. What is the ratio of the ODA received (in %) in Middle income in 2003 to that in 2009?
Provide a short and direct response. 1.74. What is the ratio of the ODA received (in %) of Tanzania in 2003 to that in 2009?
Your answer should be very brief. 1.89. What is the ratio of the ODA received (in %) in Vietnam in 2003 to that in 2009?
Your response must be concise. 1.33. What is the ratio of the ODA received (in %) of East Asia (developing only) in 2003 to that in 2010?
Make the answer very short. 2.93. What is the ratio of the ODA received (in %) of Middle income in 2003 to that in 2010?
Offer a very short reply. 2.28. What is the ratio of the ODA received (in %) in Tanzania in 2003 to that in 2010?
Provide a short and direct response. 2.24. What is the ratio of the ODA received (in %) of Vietnam in 2003 to that in 2010?
Give a very brief answer. 1.78. What is the ratio of the ODA received (in %) in East Asia (developing only) in 2004 to that in 2005?
Provide a short and direct response. 0.84. What is the ratio of the ODA received (in %) of Middle income in 2004 to that in 2005?
Provide a succinct answer. 0.68. What is the ratio of the ODA received (in %) of Tanzania in 2004 to that in 2005?
Ensure brevity in your answer.  1.48. What is the ratio of the ODA received (in %) in Vietnam in 2004 to that in 2005?
Provide a succinct answer. 1.17. What is the ratio of the ODA received (in %) of East Asia (developing only) in 2004 to that in 2006?
Provide a succinct answer. 1.25. What is the ratio of the ODA received (in %) of Middle income in 2004 to that in 2006?
Make the answer very short. 0.92. What is the ratio of the ODA received (in %) of Tanzania in 2004 to that in 2006?
Your response must be concise. 1.58. What is the ratio of the ODA received (in %) of Vietnam in 2004 to that in 2006?
Your answer should be compact. 1.42. What is the ratio of the ODA received (in %) of East Asia (developing only) in 2004 to that in 2007?
Make the answer very short. 1.39. What is the ratio of the ODA received (in %) of Middle income in 2004 to that in 2007?
Ensure brevity in your answer.  1.36. What is the ratio of the ODA received (in %) in Tanzania in 2004 to that in 2007?
Provide a short and direct response. 1.53. What is the ratio of the ODA received (in %) in Vietnam in 2004 to that in 2007?
Provide a short and direct response. 1.4. What is the ratio of the ODA received (in %) of East Asia (developing only) in 2004 to that in 2008?
Make the answer very short. 1.81. What is the ratio of the ODA received (in %) of Middle income in 2004 to that in 2008?
Provide a short and direct response. 1.51. What is the ratio of the ODA received (in %) in Tanzania in 2004 to that in 2008?
Keep it short and to the point. 2.31. What is the ratio of the ODA received (in %) in Vietnam in 2004 to that in 2008?
Provide a succinct answer. 1.62. What is the ratio of the ODA received (in %) of East Asia (developing only) in 2004 to that in 2009?
Provide a short and direct response. 1.89. What is the ratio of the ODA received (in %) in Middle income in 2004 to that in 2009?
Offer a terse response. 1.64. What is the ratio of the ODA received (in %) in Tanzania in 2004 to that in 2009?
Offer a very short reply. 1.5. What is the ratio of the ODA received (in %) in Vietnam in 2004 to that in 2009?
Give a very brief answer. 1.21. What is the ratio of the ODA received (in %) of East Asia (developing only) in 2004 to that in 2010?
Offer a very short reply. 2.37. What is the ratio of the ODA received (in %) of Middle income in 2004 to that in 2010?
Give a very brief answer. 2.14. What is the ratio of the ODA received (in %) in Tanzania in 2004 to that in 2010?
Ensure brevity in your answer.  1.77. What is the ratio of the ODA received (in %) in Vietnam in 2004 to that in 2010?
Ensure brevity in your answer.  1.61. What is the ratio of the ODA received (in %) in East Asia (developing only) in 2005 to that in 2006?
Provide a short and direct response. 1.5. What is the ratio of the ODA received (in %) in Middle income in 2005 to that in 2006?
Make the answer very short. 1.35. What is the ratio of the ODA received (in %) of Tanzania in 2005 to that in 2006?
Your response must be concise. 1.06. What is the ratio of the ODA received (in %) in Vietnam in 2005 to that in 2006?
Provide a succinct answer. 1.22. What is the ratio of the ODA received (in %) in East Asia (developing only) in 2005 to that in 2007?
Provide a succinct answer. 1.66. What is the ratio of the ODA received (in %) of Middle income in 2005 to that in 2007?
Ensure brevity in your answer.  2. What is the ratio of the ODA received (in %) in Tanzania in 2005 to that in 2007?
Provide a short and direct response. 1.03. What is the ratio of the ODA received (in %) of Vietnam in 2005 to that in 2007?
Your response must be concise. 1.2. What is the ratio of the ODA received (in %) of East Asia (developing only) in 2005 to that in 2008?
Your response must be concise. 2.16. What is the ratio of the ODA received (in %) of Middle income in 2005 to that in 2008?
Ensure brevity in your answer.  2.22. What is the ratio of the ODA received (in %) of Tanzania in 2005 to that in 2008?
Your answer should be very brief. 1.55. What is the ratio of the ODA received (in %) in Vietnam in 2005 to that in 2008?
Your answer should be compact. 1.39. What is the ratio of the ODA received (in %) of East Asia (developing only) in 2005 to that in 2009?
Keep it short and to the point. 2.26. What is the ratio of the ODA received (in %) in Middle income in 2005 to that in 2009?
Keep it short and to the point. 2.4. What is the ratio of the ODA received (in %) of Tanzania in 2005 to that in 2009?
Give a very brief answer. 1.01. What is the ratio of the ODA received (in %) in Vietnam in 2005 to that in 2009?
Your response must be concise. 1.04. What is the ratio of the ODA received (in %) in East Asia (developing only) in 2005 to that in 2010?
Offer a terse response. 2.84. What is the ratio of the ODA received (in %) in Middle income in 2005 to that in 2010?
Ensure brevity in your answer.  3.13. What is the ratio of the ODA received (in %) of Tanzania in 2005 to that in 2010?
Offer a terse response. 1.2. What is the ratio of the ODA received (in %) in Vietnam in 2005 to that in 2010?
Ensure brevity in your answer.  1.38. What is the ratio of the ODA received (in %) of East Asia (developing only) in 2006 to that in 2007?
Your answer should be compact. 1.11. What is the ratio of the ODA received (in %) of Middle income in 2006 to that in 2007?
Provide a short and direct response. 1.48. What is the ratio of the ODA received (in %) of Tanzania in 2006 to that in 2007?
Give a very brief answer. 0.97. What is the ratio of the ODA received (in %) in Vietnam in 2006 to that in 2007?
Make the answer very short. 0.98. What is the ratio of the ODA received (in %) in East Asia (developing only) in 2006 to that in 2008?
Offer a very short reply. 1.44. What is the ratio of the ODA received (in %) of Middle income in 2006 to that in 2008?
Provide a short and direct response. 1.64. What is the ratio of the ODA received (in %) in Tanzania in 2006 to that in 2008?
Keep it short and to the point. 1.46. What is the ratio of the ODA received (in %) in Vietnam in 2006 to that in 2008?
Offer a terse response. 1.14. What is the ratio of the ODA received (in %) in East Asia (developing only) in 2006 to that in 2009?
Keep it short and to the point. 1.51. What is the ratio of the ODA received (in %) of Middle income in 2006 to that in 2009?
Make the answer very short. 1.78. What is the ratio of the ODA received (in %) in Tanzania in 2006 to that in 2009?
Your answer should be very brief. 0.95. What is the ratio of the ODA received (in %) in Vietnam in 2006 to that in 2009?
Ensure brevity in your answer.  0.85. What is the ratio of the ODA received (in %) in East Asia (developing only) in 2006 to that in 2010?
Offer a very short reply. 1.9. What is the ratio of the ODA received (in %) of Middle income in 2006 to that in 2010?
Your answer should be very brief. 2.32. What is the ratio of the ODA received (in %) in Tanzania in 2006 to that in 2010?
Offer a very short reply. 1.13. What is the ratio of the ODA received (in %) of Vietnam in 2006 to that in 2010?
Your answer should be very brief. 1.13. What is the ratio of the ODA received (in %) in East Asia (developing only) in 2007 to that in 2008?
Your answer should be compact. 1.3. What is the ratio of the ODA received (in %) in Middle income in 2007 to that in 2008?
Make the answer very short. 1.11. What is the ratio of the ODA received (in %) of Tanzania in 2007 to that in 2008?
Ensure brevity in your answer.  1.5. What is the ratio of the ODA received (in %) of Vietnam in 2007 to that in 2008?
Your answer should be very brief. 1.16. What is the ratio of the ODA received (in %) in East Asia (developing only) in 2007 to that in 2009?
Your answer should be compact. 1.36. What is the ratio of the ODA received (in %) of Middle income in 2007 to that in 2009?
Provide a succinct answer. 1.2. What is the ratio of the ODA received (in %) of Tanzania in 2007 to that in 2009?
Keep it short and to the point. 0.98. What is the ratio of the ODA received (in %) in Vietnam in 2007 to that in 2009?
Provide a succinct answer. 0.87. What is the ratio of the ODA received (in %) of East Asia (developing only) in 2007 to that in 2010?
Make the answer very short. 1.71. What is the ratio of the ODA received (in %) in Middle income in 2007 to that in 2010?
Make the answer very short. 1.57. What is the ratio of the ODA received (in %) in Tanzania in 2007 to that in 2010?
Your response must be concise. 1.16. What is the ratio of the ODA received (in %) in Vietnam in 2007 to that in 2010?
Your answer should be very brief. 1.15. What is the ratio of the ODA received (in %) of East Asia (developing only) in 2008 to that in 2009?
Keep it short and to the point. 1.05. What is the ratio of the ODA received (in %) of Middle income in 2008 to that in 2009?
Offer a very short reply. 1.08. What is the ratio of the ODA received (in %) in Tanzania in 2008 to that in 2009?
Make the answer very short. 0.65. What is the ratio of the ODA received (in %) in Vietnam in 2008 to that in 2009?
Your answer should be compact. 0.74. What is the ratio of the ODA received (in %) in East Asia (developing only) in 2008 to that in 2010?
Give a very brief answer. 1.31. What is the ratio of the ODA received (in %) in Middle income in 2008 to that in 2010?
Make the answer very short. 1.41. What is the ratio of the ODA received (in %) of Tanzania in 2008 to that in 2010?
Your answer should be compact. 0.77. What is the ratio of the ODA received (in %) of Vietnam in 2008 to that in 2010?
Keep it short and to the point. 0.99. What is the ratio of the ODA received (in %) of East Asia (developing only) in 2009 to that in 2010?
Offer a terse response. 1.26. What is the ratio of the ODA received (in %) of Middle income in 2009 to that in 2010?
Offer a terse response. 1.3. What is the ratio of the ODA received (in %) in Tanzania in 2009 to that in 2010?
Ensure brevity in your answer.  1.18. What is the ratio of the ODA received (in %) of Vietnam in 2009 to that in 2010?
Your answer should be compact. 1.33. What is the difference between the highest and the second highest ODA received (in %) of East Asia (developing only)?
Offer a very short reply. 0.03. What is the difference between the highest and the second highest ODA received (in %) of Middle income?
Offer a terse response. 0.71. What is the difference between the highest and the second highest ODA received (in %) of Tanzania?
Offer a very short reply. 15.98. What is the difference between the highest and the second highest ODA received (in %) in Vietnam?
Keep it short and to the point. 1.18. What is the difference between the highest and the lowest ODA received (in %) in East Asia (developing only)?
Provide a succinct answer. 0.56. What is the difference between the highest and the lowest ODA received (in %) in Middle income?
Offer a very short reply. 1.85. What is the difference between the highest and the lowest ODA received (in %) in Tanzania?
Give a very brief answer. 50.65. What is the difference between the highest and the lowest ODA received (in %) of Vietnam?
Keep it short and to the point. 5.58. 